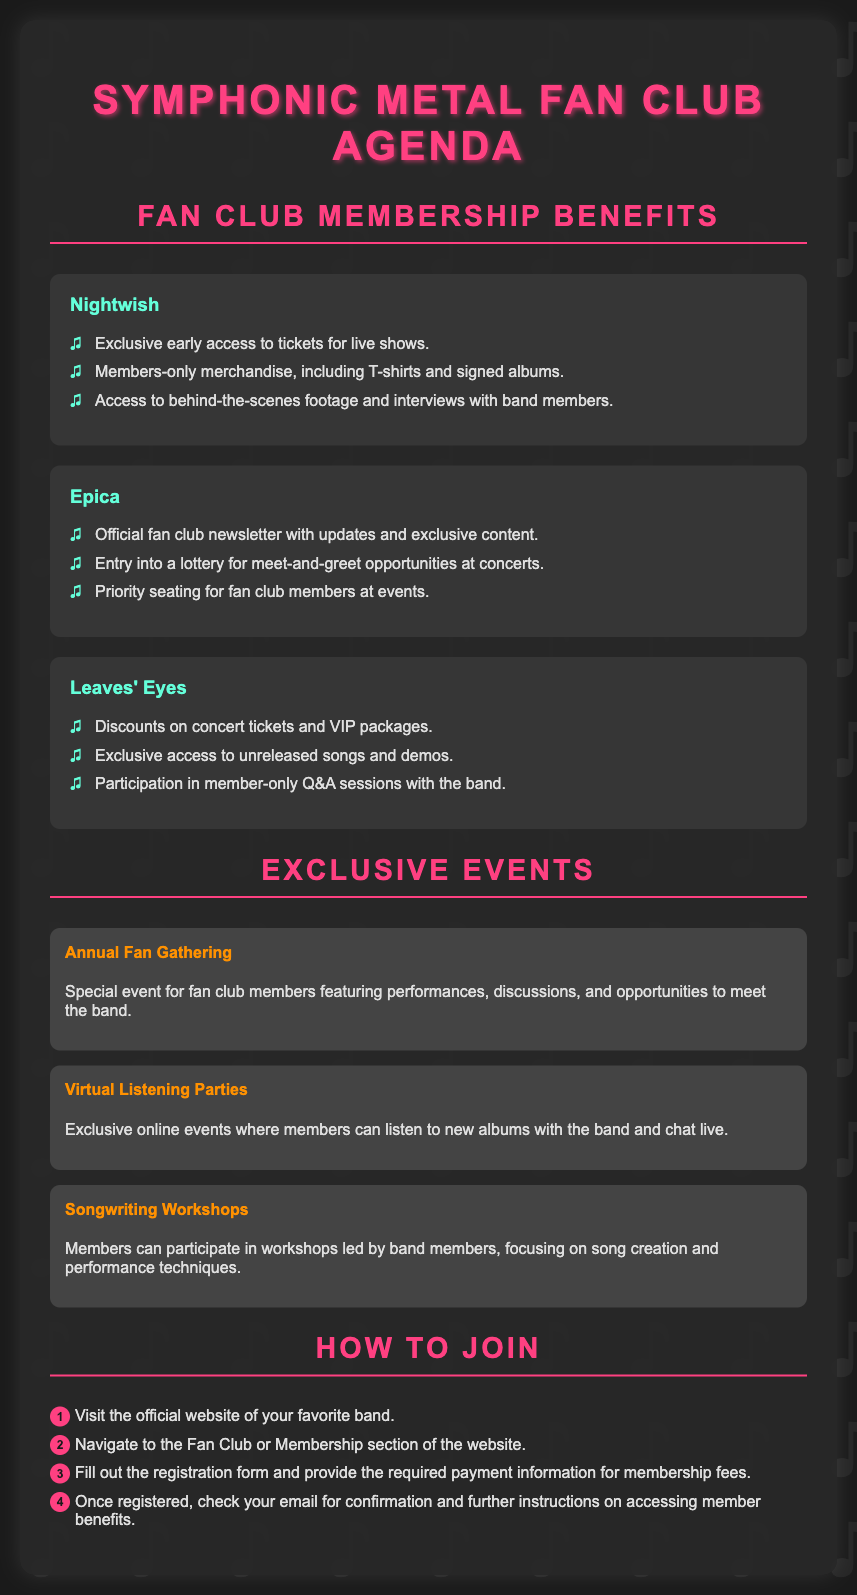what are the benefits of joining Nightwish fan club? The benefits include exclusive early access to tickets, members-only merchandise, and access to behind-the-scenes footage and interviews.
Answer: exclusive early access to tickets, members-only merchandise, access to behind-the-scenes footage which band offers priority seating for events? This benefit is mentioned in the context of Epica's fan club membership.
Answer: Epica how many exclusive events are listed in the document? The document lists a total of three exclusive events described under "Exclusive Events."
Answer: three what is the first step to join the fan club? The first step involves visiting the official website of your favorite band.
Answer: visit the official website what kind of sessions can members participate in with Leaves' Eyes? Members can participate in member-only Q&A sessions with Leaves' Eyes.
Answer: member-only Q&A sessions what type of event is the Annual Fan Gathering? It is described as a special event featuring performances, discussions, and opportunities to meet the band.
Answer: special event who offers discounts on concert tickets? Leaves' Eyes offers discounts on concert tickets as a membership benefit.
Answer: Leaves' Eyes how can members listen to new albums with the band? Members can join virtual listening parties where they can listen to new albums and chat live.
Answer: virtual listening parties which step involves providing payment information? Step three mentions filling out the registration form and providing payment information.
Answer: providing payment information 